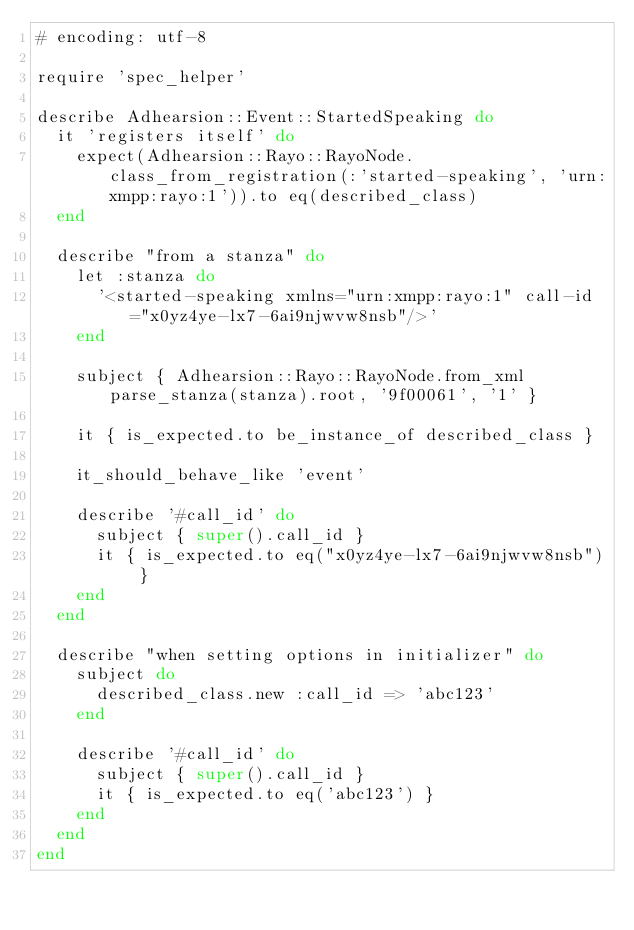<code> <loc_0><loc_0><loc_500><loc_500><_Ruby_># encoding: utf-8

require 'spec_helper'

describe Adhearsion::Event::StartedSpeaking do
  it 'registers itself' do
    expect(Adhearsion::Rayo::RayoNode.class_from_registration(:'started-speaking', 'urn:xmpp:rayo:1')).to eq(described_class)
  end

  describe "from a stanza" do
    let :stanza do
      '<started-speaking xmlns="urn:xmpp:rayo:1" call-id="x0yz4ye-lx7-6ai9njwvw8nsb"/>'
    end

    subject { Adhearsion::Rayo::RayoNode.from_xml parse_stanza(stanza).root, '9f00061', '1' }

    it { is_expected.to be_instance_of described_class }

    it_should_behave_like 'event'

    describe '#call_id' do
      subject { super().call_id }
      it { is_expected.to eq("x0yz4ye-lx7-6ai9njwvw8nsb") }
    end
  end

  describe "when setting options in initializer" do
    subject do
      described_class.new :call_id => 'abc123'
    end

    describe '#call_id' do
      subject { super().call_id }
      it { is_expected.to eq('abc123') }
    end
  end
end
</code> 